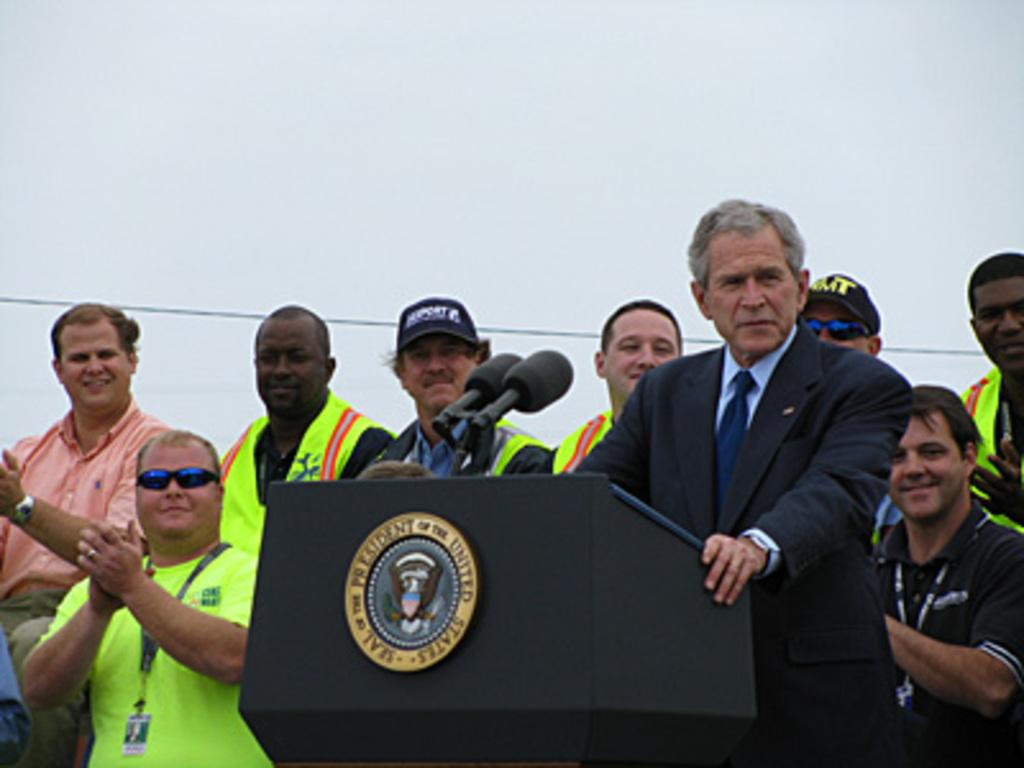How many people are in the image? There are people in the image, but the exact number is not specified. What is one person doing with their hands in the image? One person is resting their hands on a podium in the image. What objects are present for amplifying sound? There are microphones in the image. What type of material can be seen in the image? Wire is visible in the image. What can be seen behind the people and objects in the image? The background of the image is visible. Can you see a trail leading up a hill in the background of the image? There is no trail or hill visible in the background of the image. Is there a spring providing water for the people in the image? There is no spring or water source mentioned or visible in the image. 